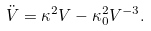Convert formula to latex. <formula><loc_0><loc_0><loc_500><loc_500>\ddot { V } = \kappa ^ { 2 } V - \kappa _ { 0 } ^ { 2 } V ^ { - 3 } .</formula> 